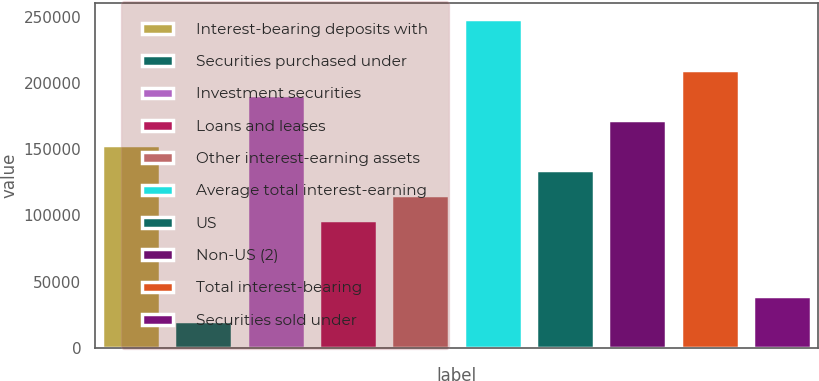Convert chart. <chart><loc_0><loc_0><loc_500><loc_500><bar_chart><fcel>Interest-bearing deposits with<fcel>Securities purchased under<fcel>Investment securities<fcel>Loans and leases<fcel>Other interest-earning assets<fcel>Average total interest-earning<fcel>US<fcel>Non-US (2)<fcel>Total interest-bearing<fcel>Securities sold under<nl><fcel>153251<fcel>20305.2<fcel>191235<fcel>96274<fcel>115266<fcel>248212<fcel>134258<fcel>172243<fcel>210227<fcel>39297.4<nl></chart> 